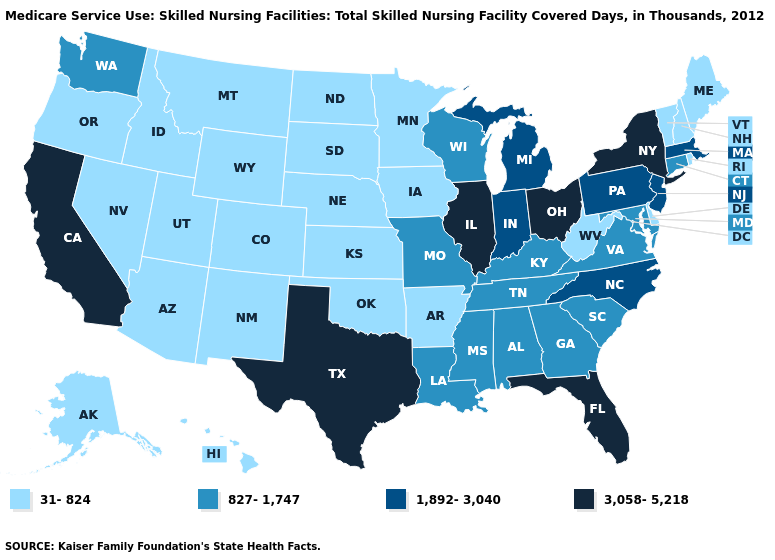Name the states that have a value in the range 1,892-3,040?
Quick response, please. Indiana, Massachusetts, Michigan, New Jersey, North Carolina, Pennsylvania. What is the value of New Mexico?
Short answer required. 31-824. What is the highest value in the USA?
Be succinct. 3,058-5,218. What is the value of Idaho?
Keep it brief. 31-824. Does the map have missing data?
Quick response, please. No. Name the states that have a value in the range 1,892-3,040?
Concise answer only. Indiana, Massachusetts, Michigan, New Jersey, North Carolina, Pennsylvania. How many symbols are there in the legend?
Short answer required. 4. How many symbols are there in the legend?
Keep it brief. 4. What is the lowest value in the MidWest?
Short answer required. 31-824. Which states have the lowest value in the USA?
Write a very short answer. Alaska, Arizona, Arkansas, Colorado, Delaware, Hawaii, Idaho, Iowa, Kansas, Maine, Minnesota, Montana, Nebraska, Nevada, New Hampshire, New Mexico, North Dakota, Oklahoma, Oregon, Rhode Island, South Dakota, Utah, Vermont, West Virginia, Wyoming. Does Ohio have the same value as Texas?
Quick response, please. Yes. Name the states that have a value in the range 3,058-5,218?
Quick response, please. California, Florida, Illinois, New York, Ohio, Texas. What is the value of Nebraska?
Give a very brief answer. 31-824. Which states have the highest value in the USA?
Keep it brief. California, Florida, Illinois, New York, Ohio, Texas. Does Indiana have the same value as Washington?
Short answer required. No. 